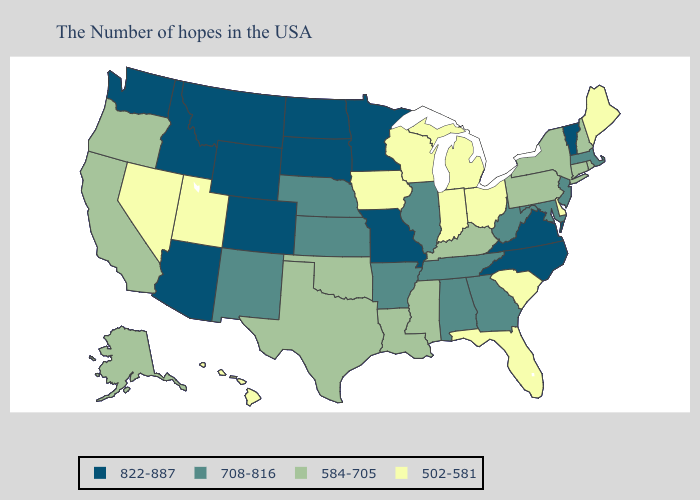Among the states that border New Mexico , does Colorado have the highest value?
Answer briefly. Yes. What is the highest value in states that border West Virginia?
Be succinct. 822-887. Does Nebraska have the highest value in the MidWest?
Quick response, please. No. Which states have the lowest value in the Northeast?
Quick response, please. Maine. Name the states that have a value in the range 708-816?
Answer briefly. Massachusetts, New Jersey, Maryland, West Virginia, Georgia, Alabama, Tennessee, Illinois, Arkansas, Kansas, Nebraska, New Mexico. How many symbols are there in the legend?
Answer briefly. 4. How many symbols are there in the legend?
Keep it brief. 4. What is the lowest value in the USA?
Concise answer only. 502-581. Name the states that have a value in the range 822-887?
Write a very short answer. Vermont, Virginia, North Carolina, Missouri, Minnesota, South Dakota, North Dakota, Wyoming, Colorado, Montana, Arizona, Idaho, Washington. Does the first symbol in the legend represent the smallest category?
Answer briefly. No. What is the highest value in the USA?
Be succinct. 822-887. Does South Carolina have the lowest value in the South?
Quick response, please. Yes. Name the states that have a value in the range 502-581?
Concise answer only. Maine, Delaware, South Carolina, Ohio, Florida, Michigan, Indiana, Wisconsin, Iowa, Utah, Nevada, Hawaii. Does Virginia have the highest value in the USA?
Quick response, please. Yes. 